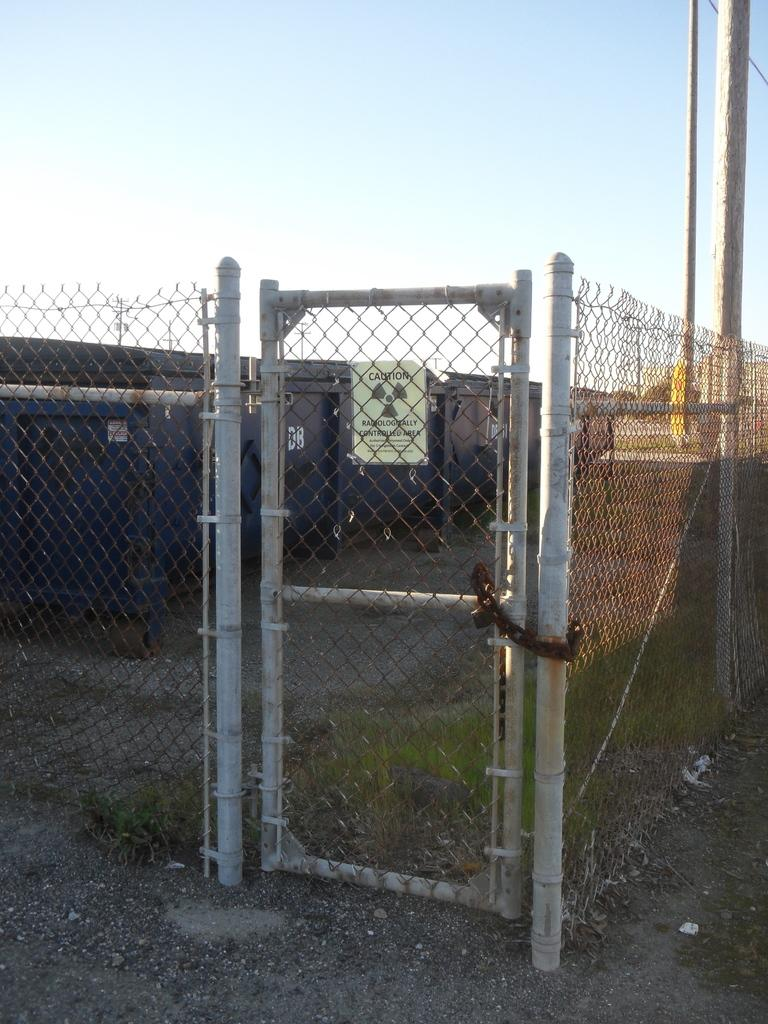What type of barrier is present in the image? There is a fence in the image. What feature is present for entering or exiting a space in the image? There is a door in the image. What type of structure can be seen in the background of the image? There is a building in the background of the image. What are the tall, thin objects in the background of the image? There are poles in the background of the image. What part of the natural environment is visible in the image? The sky is visible in the background of the image. How many spiders are crawling on the door in the image? There are no spiders present in the image. What type of fingerprints can be seen on the fence in the image? There are no fingerprints visible on the fence in the image. 